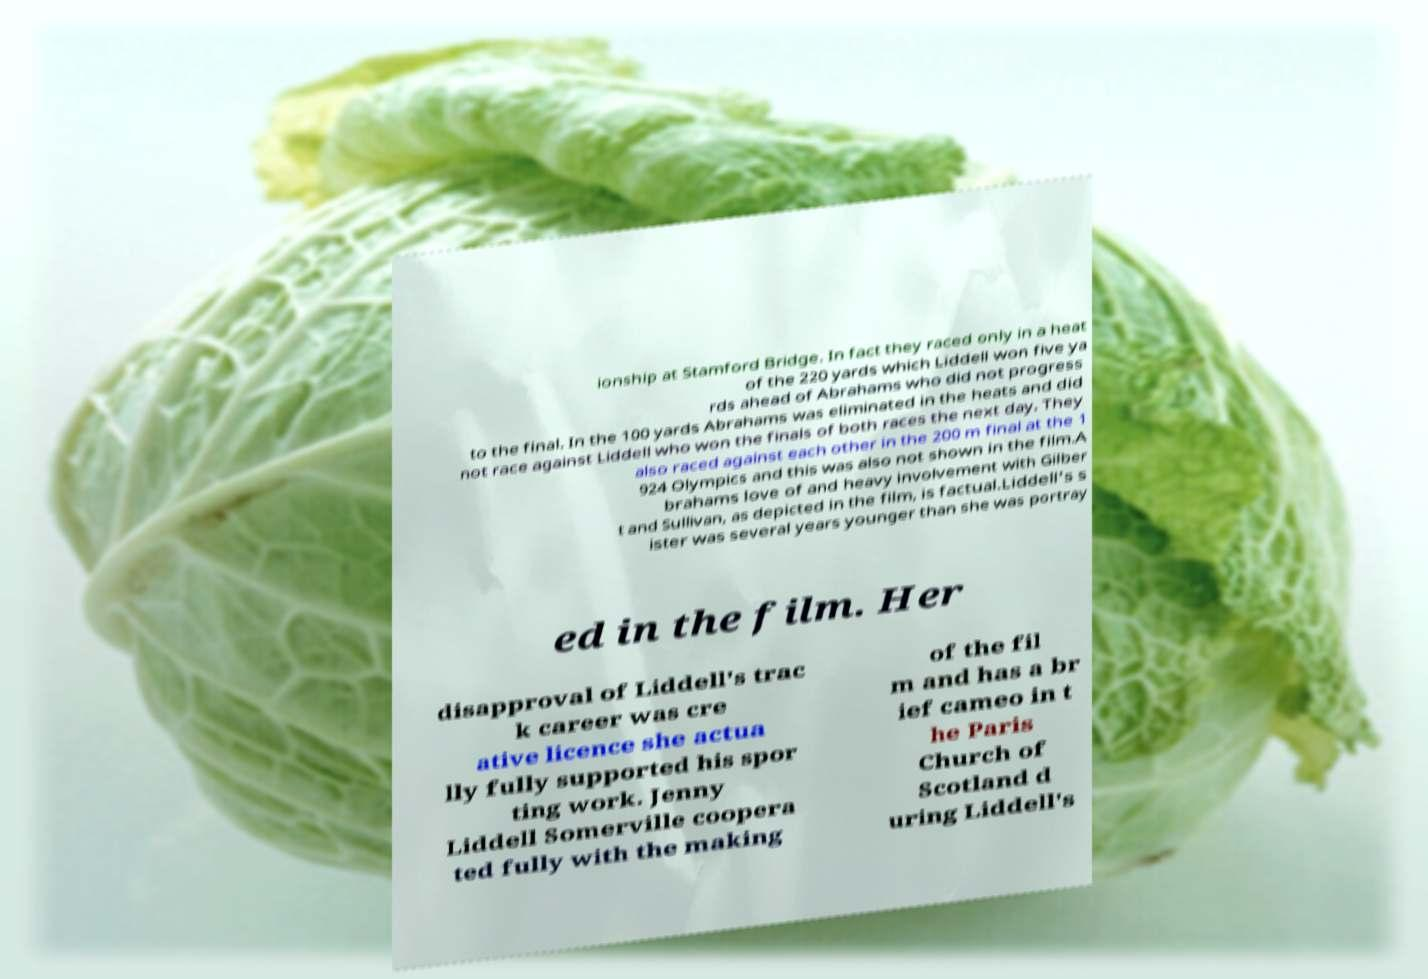Can you read and provide the text displayed in the image?This photo seems to have some interesting text. Can you extract and type it out for me? ionship at Stamford Bridge. In fact they raced only in a heat of the 220 yards which Liddell won five ya rds ahead of Abrahams who did not progress to the final. In the 100 yards Abrahams was eliminated in the heats and did not race against Liddell who won the finals of both races the next day. They also raced against each other in the 200 m final at the 1 924 Olympics and this was also not shown in the film.A brahams love of and heavy involvement with Gilber t and Sullivan, as depicted in the film, is factual.Liddell's s ister was several years younger than she was portray ed in the film. Her disapproval of Liddell's trac k career was cre ative licence she actua lly fully supported his spor ting work. Jenny Liddell Somerville coopera ted fully with the making of the fil m and has a br ief cameo in t he Paris Church of Scotland d uring Liddell's 